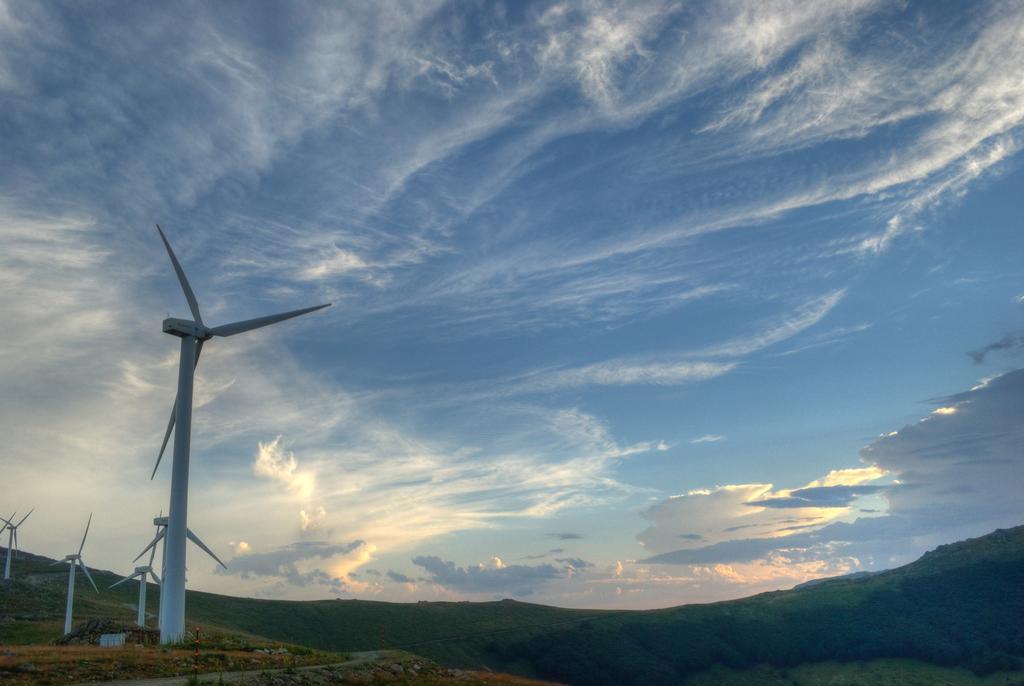Can you describe this image briefly? In this image there are wind turbines on the left side. At the top there is the sky. In the background there are hills on which there are trees and grass. 